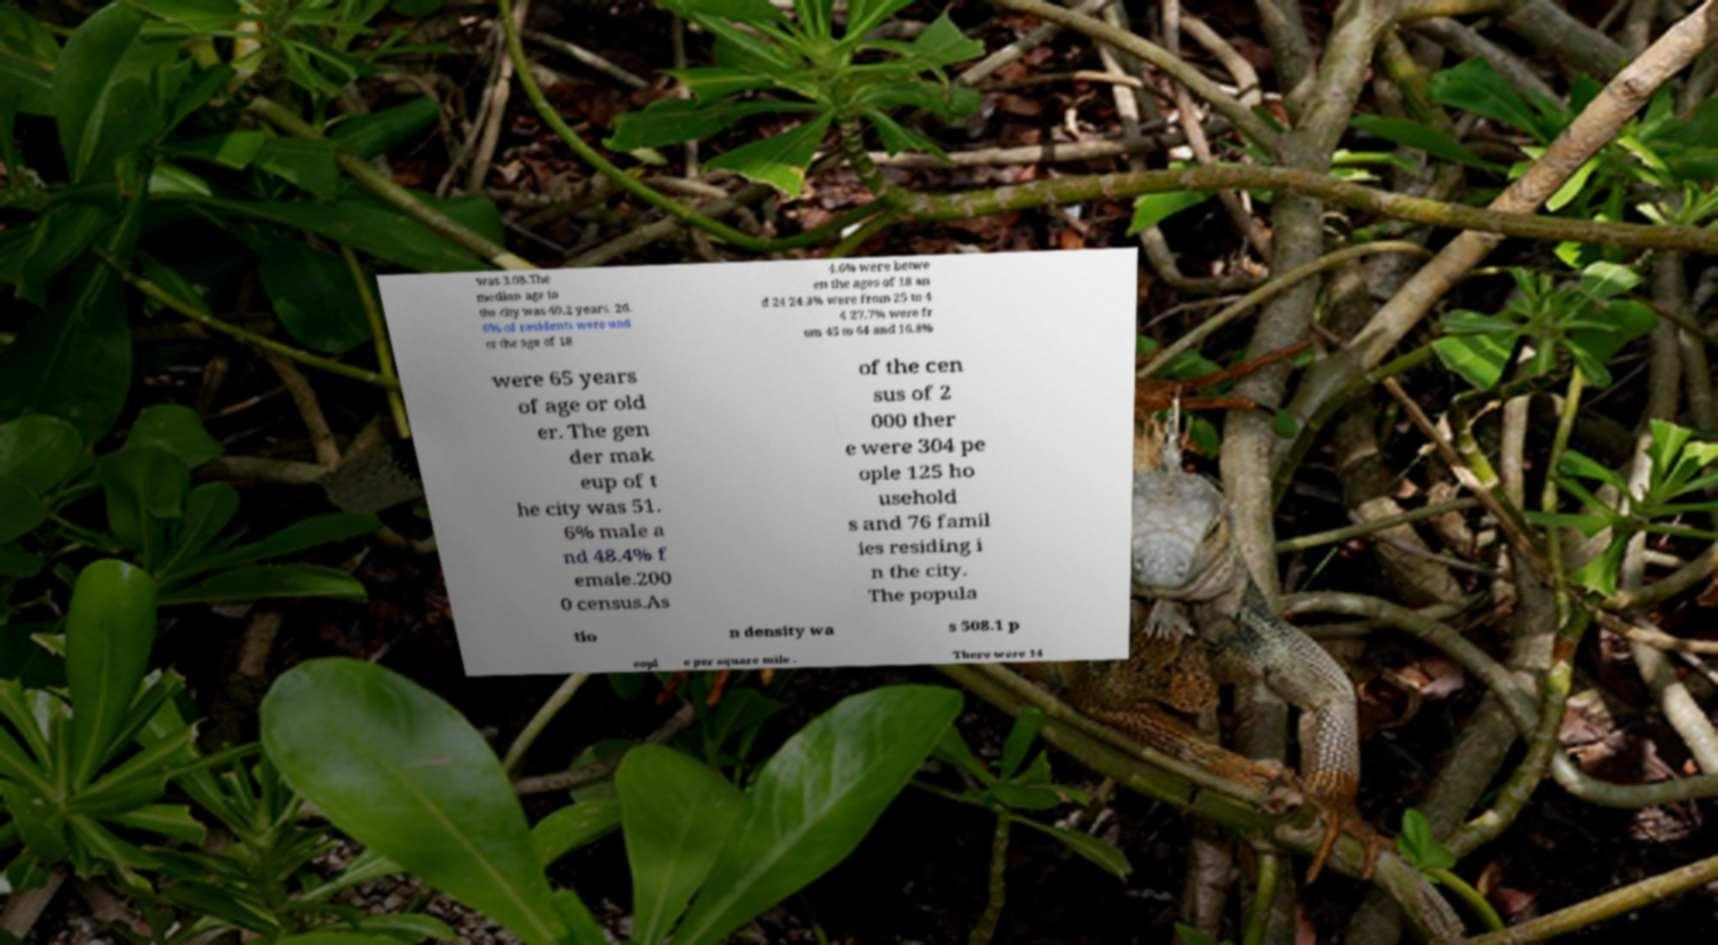Please read and relay the text visible in this image. What does it say? was 3.08.The median age in the city was 40.2 years. 26. 6% of residents were und er the age of 18 4.6% were betwe en the ages of 18 an d 24 24.3% were from 25 to 4 4 27.7% were fr om 45 to 64 and 16.8% were 65 years of age or old er. The gen der mak eup of t he city was 51. 6% male a nd 48.4% f emale.200 0 census.As of the cen sus of 2 000 ther e were 304 pe ople 125 ho usehold s and 76 famil ies residing i n the city. The popula tio n density wa s 508.1 p eopl e per square mile . There were 14 